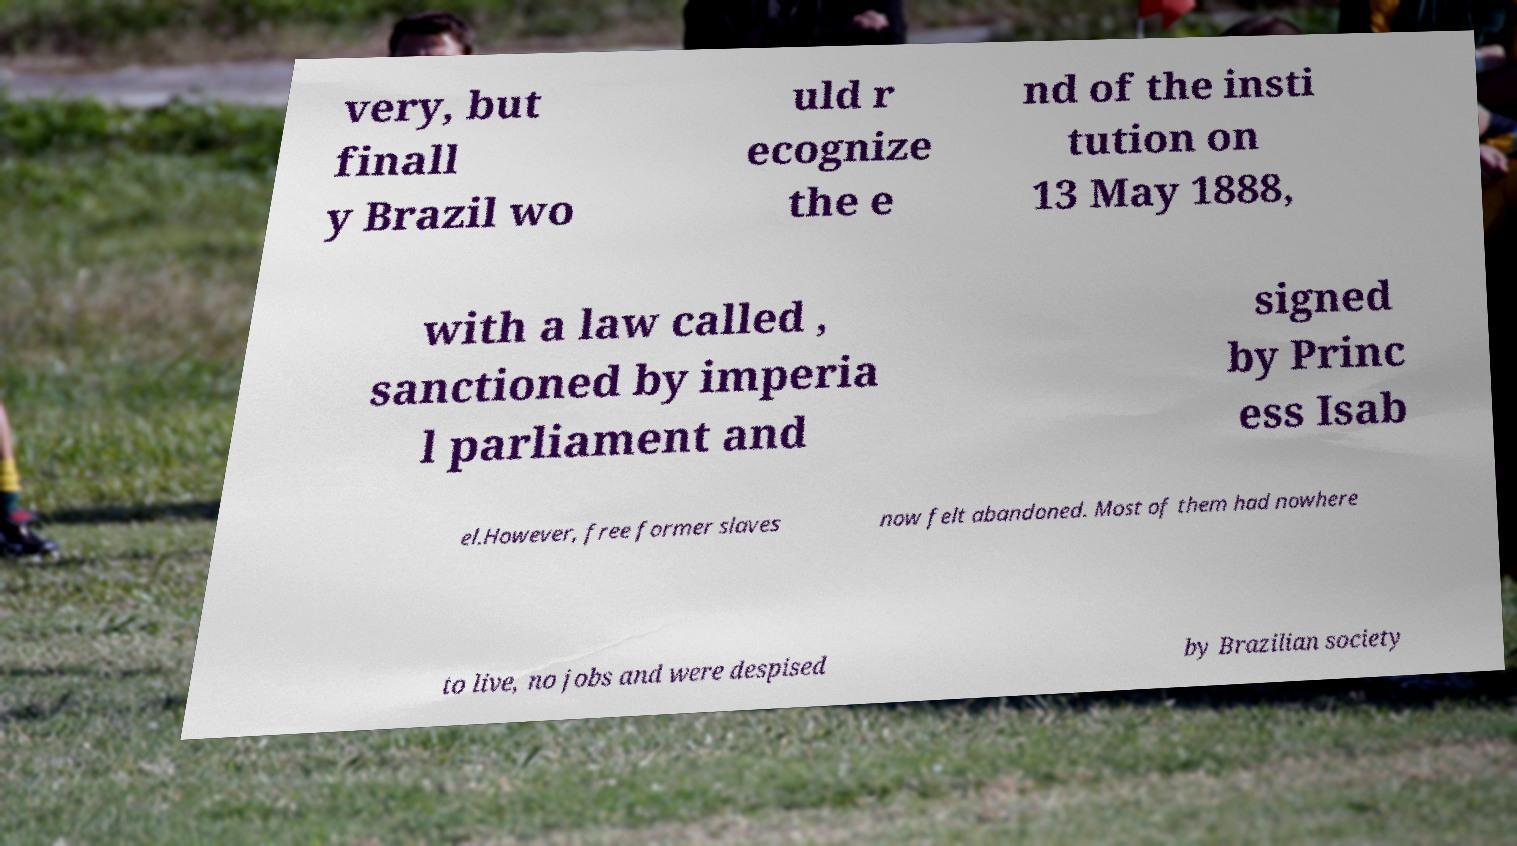What messages or text are displayed in this image? I need them in a readable, typed format. very, but finall y Brazil wo uld r ecognize the e nd of the insti tution on 13 May 1888, with a law called , sanctioned by imperia l parliament and signed by Princ ess Isab el.However, free former slaves now felt abandoned. Most of them had nowhere to live, no jobs and were despised by Brazilian society 